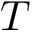<formula> <loc_0><loc_0><loc_500><loc_500>T</formula> 